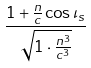<formula> <loc_0><loc_0><loc_500><loc_500>\frac { 1 + \frac { n } { c } \cos \iota _ { s } } { \sqrt { 1 \cdot \frac { n ^ { 3 } } { c ^ { 3 } } } }</formula> 